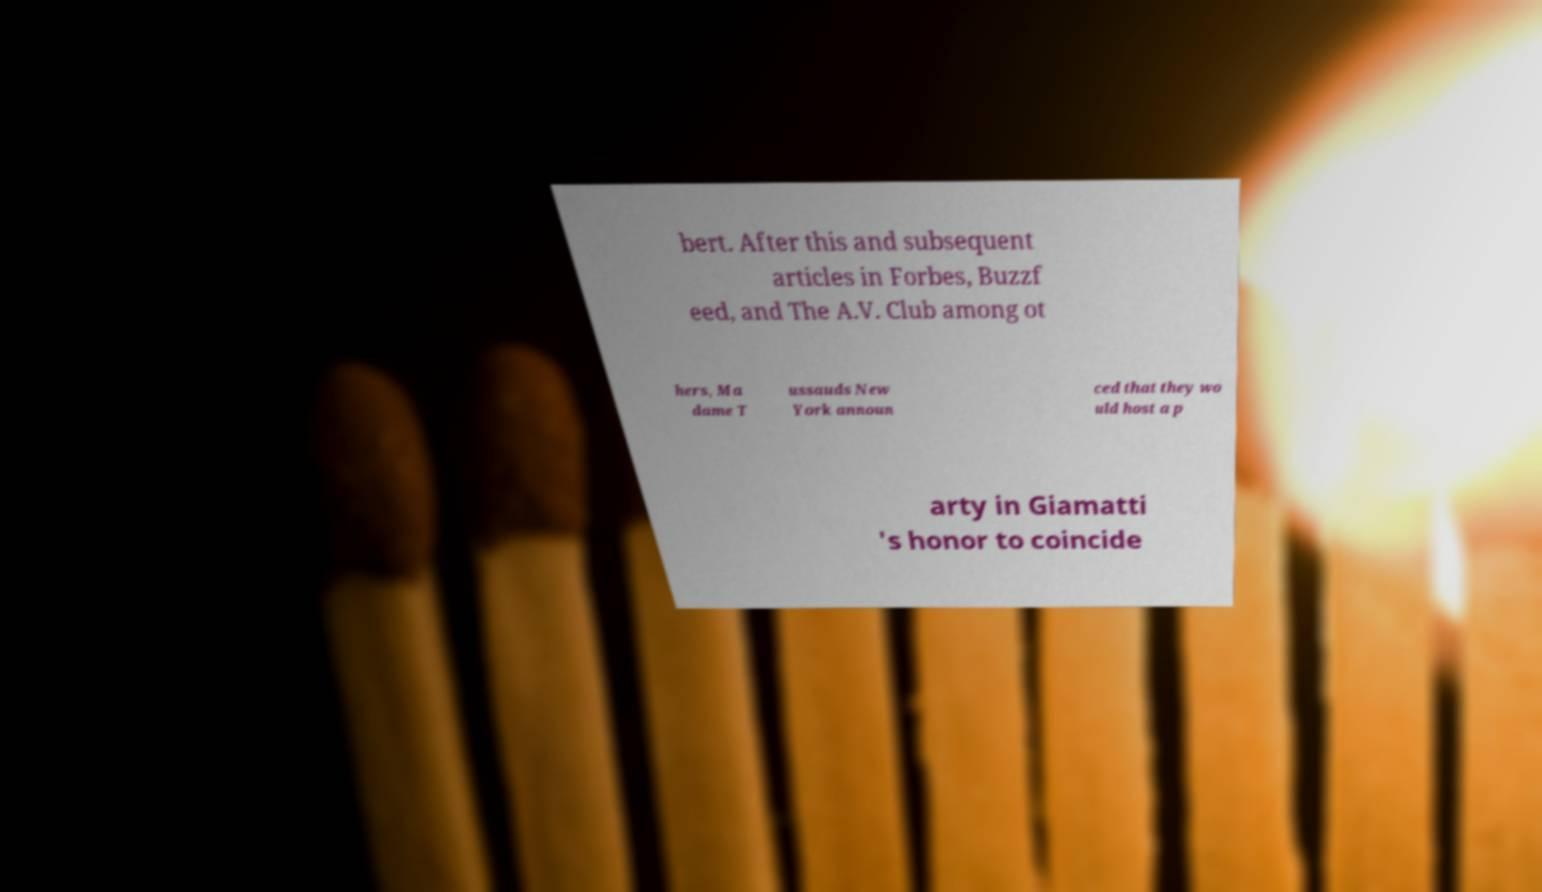Please identify and transcribe the text found in this image. bert. After this and subsequent articles in Forbes, Buzzf eed, and The A.V. Club among ot hers, Ma dame T ussauds New York announ ced that they wo uld host a p arty in Giamatti 's honor to coincide 